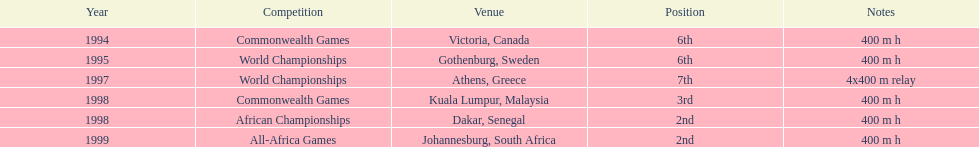What is the number of titles ken harden has one 6. Could you help me parse every detail presented in this table? {'header': ['Year', 'Competition', 'Venue', 'Position', 'Notes'], 'rows': [['1994', 'Commonwealth Games', 'Victoria, Canada', '6th', '400 m h'], ['1995', 'World Championships', 'Gothenburg, Sweden', '6th', '400 m h'], ['1997', 'World Championships', 'Athens, Greece', '7th', '4x400 m relay'], ['1998', 'Commonwealth Games', 'Kuala Lumpur, Malaysia', '3rd', '400 m h'], ['1998', 'African Championships', 'Dakar, Senegal', '2nd', '400 m h'], ['1999', 'All-Africa Games', 'Johannesburg, South Africa', '2nd', '400 m h']]} 